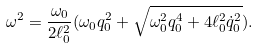Convert formula to latex. <formula><loc_0><loc_0><loc_500><loc_500>\omega ^ { 2 } = \frac { \omega _ { 0 } } { 2 \ell _ { 0 } ^ { 2 } } ( \omega _ { 0 } q _ { 0 } ^ { 2 } + \sqrt { \omega _ { 0 } ^ { 2 } q _ { 0 } ^ { 4 } + 4 \ell _ { 0 } ^ { 2 } \dot { q } _ { 0 } ^ { 2 } } ) .</formula> 